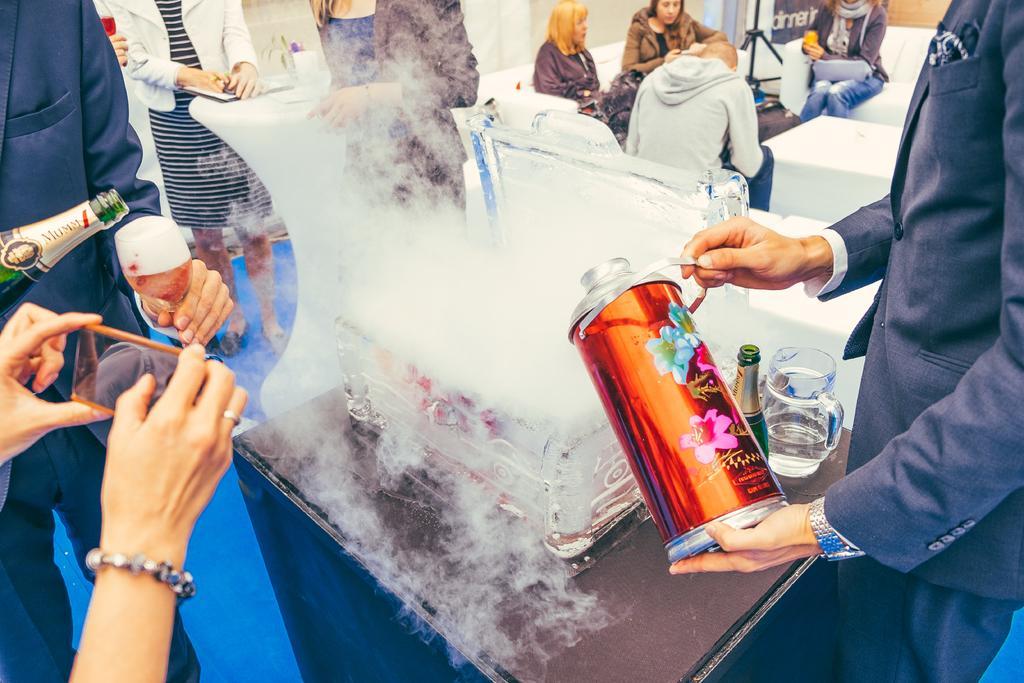Describe this image in one or two sentences. In the image in the center, we can see the smoke and few people are standing around the table. And they are holding some objects like, wine bottle, wine glass, phone, mug, etc.. On the table, we can see one container, mug and wine bottle. In the background there is a wall, stand, table, cloth and few people are sitting. 